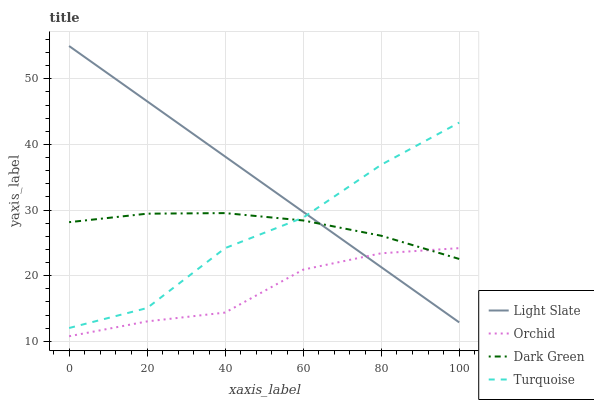Does Orchid have the minimum area under the curve?
Answer yes or no. Yes. Does Light Slate have the maximum area under the curve?
Answer yes or no. Yes. Does Turquoise have the minimum area under the curve?
Answer yes or no. No. Does Turquoise have the maximum area under the curve?
Answer yes or no. No. Is Light Slate the smoothest?
Answer yes or no. Yes. Is Turquoise the roughest?
Answer yes or no. Yes. Is Dark Green the smoothest?
Answer yes or no. No. Is Dark Green the roughest?
Answer yes or no. No. Does Orchid have the lowest value?
Answer yes or no. Yes. Does Turquoise have the lowest value?
Answer yes or no. No. Does Light Slate have the highest value?
Answer yes or no. Yes. Does Turquoise have the highest value?
Answer yes or no. No. Is Orchid less than Turquoise?
Answer yes or no. Yes. Is Turquoise greater than Orchid?
Answer yes or no. Yes. Does Orchid intersect Light Slate?
Answer yes or no. Yes. Is Orchid less than Light Slate?
Answer yes or no. No. Is Orchid greater than Light Slate?
Answer yes or no. No. Does Orchid intersect Turquoise?
Answer yes or no. No. 